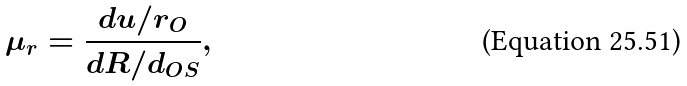Convert formula to latex. <formula><loc_0><loc_0><loc_500><loc_500>\mu _ { r } = \frac { d u / r _ { O } } { d R / d _ { O S } } ,</formula> 